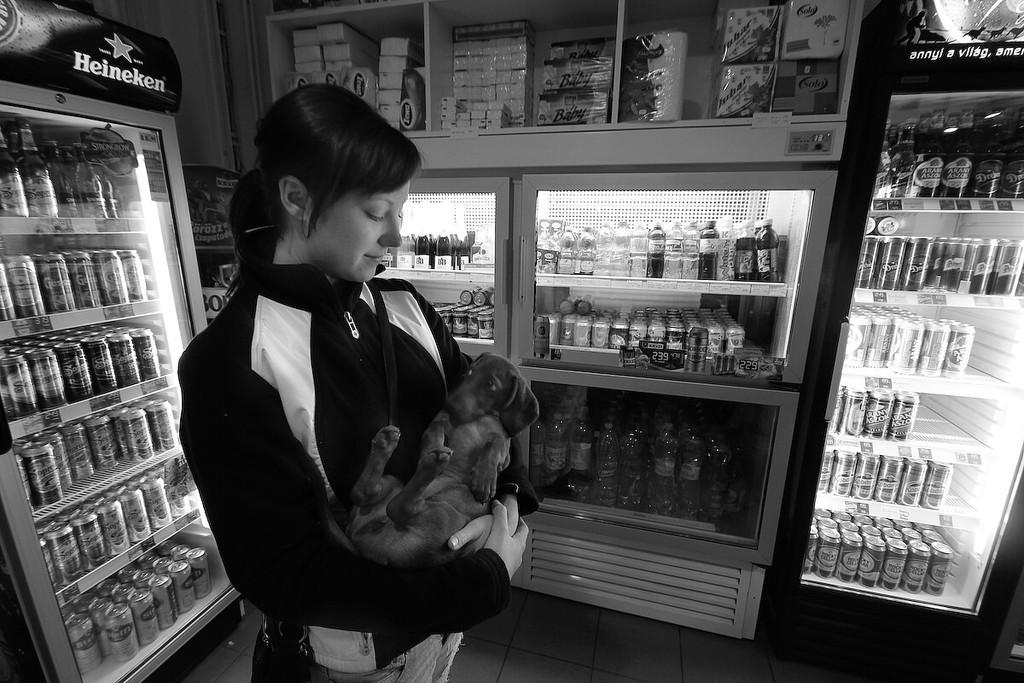In one or two sentences, can you explain what this image depicts? In the center of the image there is a woman standing and holding a dog. On the right side of the image we can see drinks and bottles in a refrigerator. On the left side of the image we can see drinks and bottles in a refrigerator. In the background we can see bottles, refrigerator and tissues. 